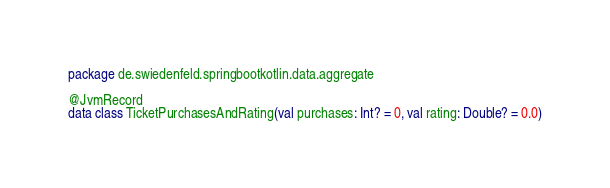<code> <loc_0><loc_0><loc_500><loc_500><_Kotlin_>package de.swiedenfeld.springbootkotlin.data.aggregate

@JvmRecord
data class TicketPurchasesAndRating(val purchases: Int? = 0, val rating: Double? = 0.0)
</code> 